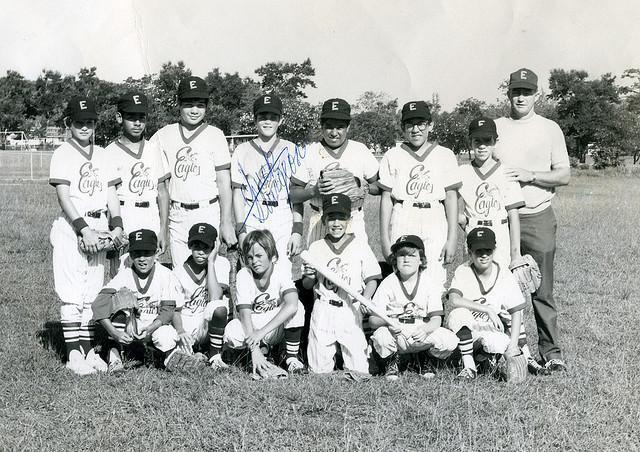How many people are in the pic?
Give a very brief answer. 14. How many men are not wearing the team uniform?
Give a very brief answer. 1. How many people are there?
Give a very brief answer. 14. How many zebras are there?
Give a very brief answer. 0. 